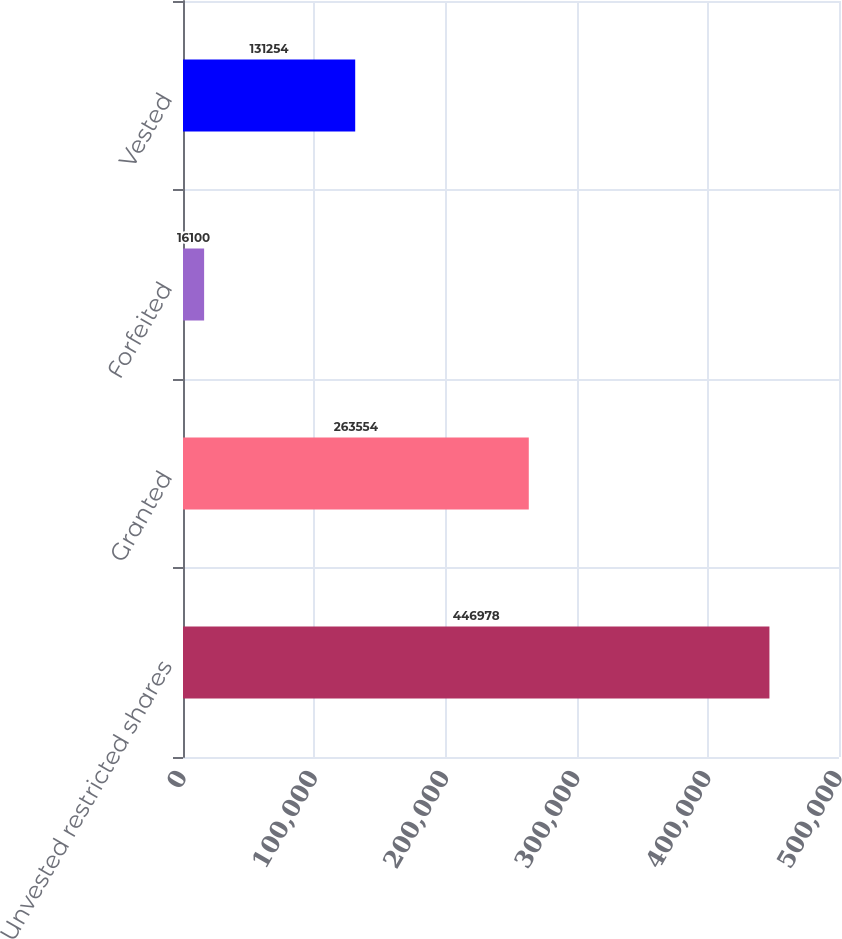Convert chart to OTSL. <chart><loc_0><loc_0><loc_500><loc_500><bar_chart><fcel>Unvested restricted shares<fcel>Granted<fcel>Forfeited<fcel>Vested<nl><fcel>446978<fcel>263554<fcel>16100<fcel>131254<nl></chart> 